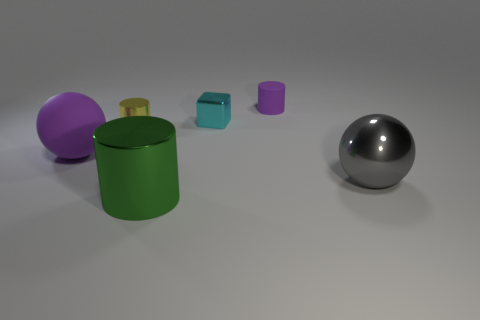There is a metallic object that is on the right side of the cube; is its size the same as the sphere that is to the left of the large gray metallic sphere? The sizes of the objects in question are not identical. The metallic object to the right of the cube, likely referring to the smaller blue cube, is distinct in size compared to the purple sphere to the left of the large silver sphere. Upon visual inspection, the purple sphere appears to be larger than the blue cube. Therefore, their sizes are not the same. 